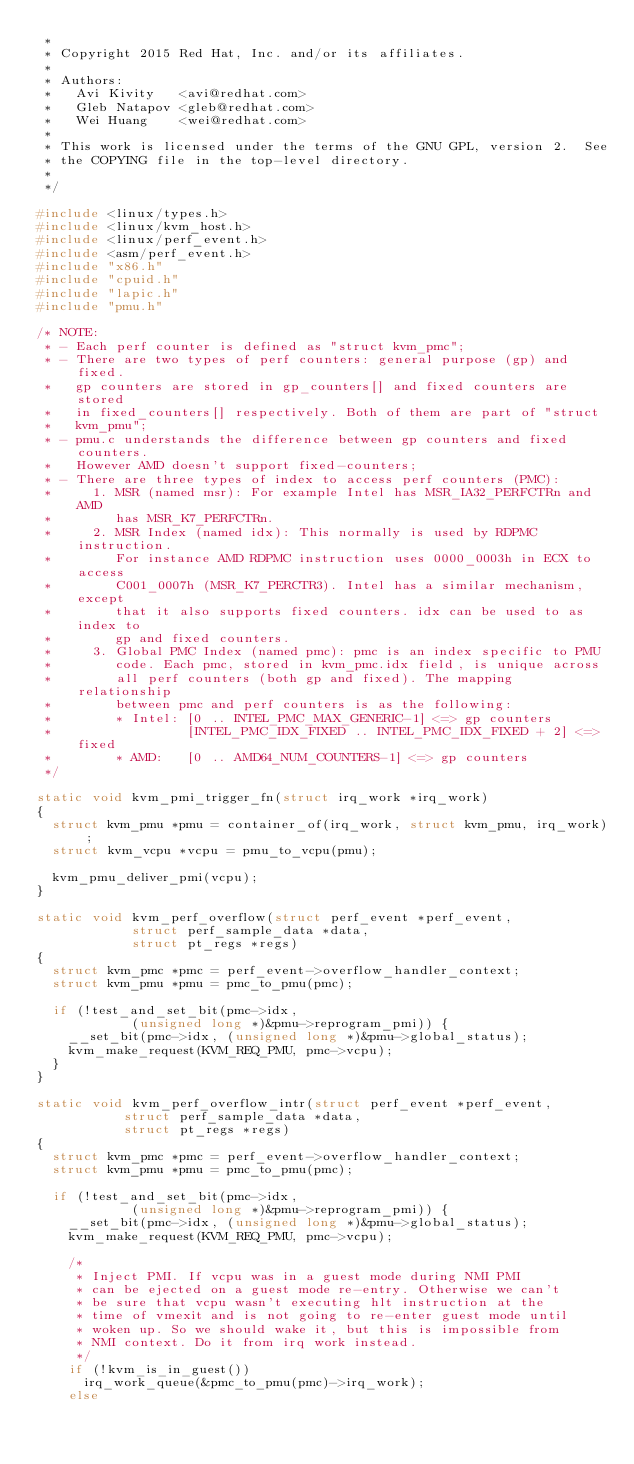Convert code to text. <code><loc_0><loc_0><loc_500><loc_500><_C_> *
 * Copyright 2015 Red Hat, Inc. and/or its affiliates.
 *
 * Authors:
 *   Avi Kivity   <avi@redhat.com>
 *   Gleb Natapov <gleb@redhat.com>
 *   Wei Huang    <wei@redhat.com>
 *
 * This work is licensed under the terms of the GNU GPL, version 2.  See
 * the COPYING file in the top-level directory.
 *
 */

#include <linux/types.h>
#include <linux/kvm_host.h>
#include <linux/perf_event.h>
#include <asm/perf_event.h>
#include "x86.h"
#include "cpuid.h"
#include "lapic.h"
#include "pmu.h"

/* NOTE:
 * - Each perf counter is defined as "struct kvm_pmc";
 * - There are two types of perf counters: general purpose (gp) and fixed.
 *   gp counters are stored in gp_counters[] and fixed counters are stored
 *   in fixed_counters[] respectively. Both of them are part of "struct
 *   kvm_pmu";
 * - pmu.c understands the difference between gp counters and fixed counters.
 *   However AMD doesn't support fixed-counters;
 * - There are three types of index to access perf counters (PMC):
 *     1. MSR (named msr): For example Intel has MSR_IA32_PERFCTRn and AMD
 *        has MSR_K7_PERFCTRn.
 *     2. MSR Index (named idx): This normally is used by RDPMC instruction.
 *        For instance AMD RDPMC instruction uses 0000_0003h in ECX to access
 *        C001_0007h (MSR_K7_PERCTR3). Intel has a similar mechanism, except
 *        that it also supports fixed counters. idx can be used to as index to
 *        gp and fixed counters.
 *     3. Global PMC Index (named pmc): pmc is an index specific to PMU
 *        code. Each pmc, stored in kvm_pmc.idx field, is unique across
 *        all perf counters (both gp and fixed). The mapping relationship
 *        between pmc and perf counters is as the following:
 *        * Intel: [0 .. INTEL_PMC_MAX_GENERIC-1] <=> gp counters
 *                 [INTEL_PMC_IDX_FIXED .. INTEL_PMC_IDX_FIXED + 2] <=> fixed
 *        * AMD:   [0 .. AMD64_NUM_COUNTERS-1] <=> gp counters
 */

static void kvm_pmi_trigger_fn(struct irq_work *irq_work)
{
	struct kvm_pmu *pmu = container_of(irq_work, struct kvm_pmu, irq_work);
	struct kvm_vcpu *vcpu = pmu_to_vcpu(pmu);

	kvm_pmu_deliver_pmi(vcpu);
}

static void kvm_perf_overflow(struct perf_event *perf_event,
			      struct perf_sample_data *data,
			      struct pt_regs *regs)
{
	struct kvm_pmc *pmc = perf_event->overflow_handler_context;
	struct kvm_pmu *pmu = pmc_to_pmu(pmc);

	if (!test_and_set_bit(pmc->idx,
			      (unsigned long *)&pmu->reprogram_pmi)) {
		__set_bit(pmc->idx, (unsigned long *)&pmu->global_status);
		kvm_make_request(KVM_REQ_PMU, pmc->vcpu);
	}
}

static void kvm_perf_overflow_intr(struct perf_event *perf_event,
				   struct perf_sample_data *data,
				   struct pt_regs *regs)
{
	struct kvm_pmc *pmc = perf_event->overflow_handler_context;
	struct kvm_pmu *pmu = pmc_to_pmu(pmc);

	if (!test_and_set_bit(pmc->idx,
			      (unsigned long *)&pmu->reprogram_pmi)) {
		__set_bit(pmc->idx, (unsigned long *)&pmu->global_status);
		kvm_make_request(KVM_REQ_PMU, pmc->vcpu);

		/*
		 * Inject PMI. If vcpu was in a guest mode during NMI PMI
		 * can be ejected on a guest mode re-entry. Otherwise we can't
		 * be sure that vcpu wasn't executing hlt instruction at the
		 * time of vmexit and is not going to re-enter guest mode until
		 * woken up. So we should wake it, but this is impossible from
		 * NMI context. Do it from irq work instead.
		 */
		if (!kvm_is_in_guest())
			irq_work_queue(&pmc_to_pmu(pmc)->irq_work);
		else</code> 